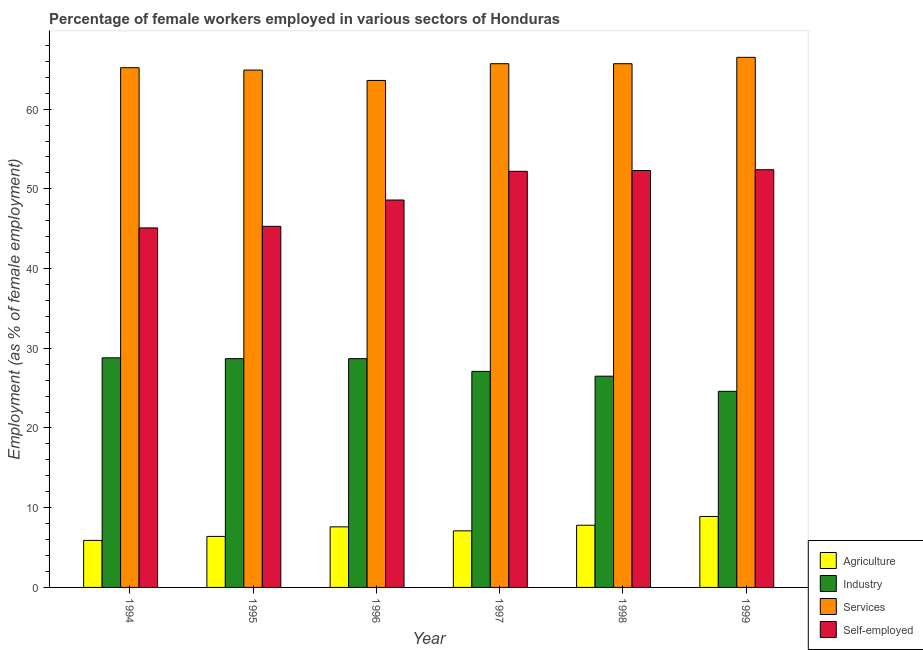How many different coloured bars are there?
Your answer should be compact. 4. Are the number of bars per tick equal to the number of legend labels?
Your response must be concise. Yes. What is the label of the 3rd group of bars from the left?
Your response must be concise. 1996. In how many cases, is the number of bars for a given year not equal to the number of legend labels?
Offer a terse response. 0. What is the percentage of female workers in industry in 1999?
Give a very brief answer. 24.6. Across all years, what is the maximum percentage of female workers in agriculture?
Your answer should be compact. 8.9. Across all years, what is the minimum percentage of female workers in agriculture?
Your answer should be very brief. 5.9. What is the total percentage of self employed female workers in the graph?
Ensure brevity in your answer.  295.9. What is the difference between the percentage of female workers in agriculture in 1994 and that in 1997?
Keep it short and to the point. -1.2. What is the average percentage of female workers in industry per year?
Offer a terse response. 27.4. In how many years, is the percentage of self employed female workers greater than 12 %?
Offer a very short reply. 6. What is the ratio of the percentage of female workers in agriculture in 1994 to that in 1997?
Your answer should be compact. 0.83. Is the percentage of self employed female workers in 1995 less than that in 1999?
Your answer should be compact. Yes. Is the difference between the percentage of self employed female workers in 1994 and 1999 greater than the difference between the percentage of female workers in services in 1994 and 1999?
Ensure brevity in your answer.  No. What is the difference between the highest and the second highest percentage of female workers in agriculture?
Your answer should be compact. 1.1. What is the difference between the highest and the lowest percentage of self employed female workers?
Offer a very short reply. 7.3. In how many years, is the percentage of female workers in services greater than the average percentage of female workers in services taken over all years?
Your answer should be compact. 3. What does the 2nd bar from the left in 1996 represents?
Ensure brevity in your answer.  Industry. What does the 3rd bar from the right in 1998 represents?
Offer a very short reply. Industry. Are all the bars in the graph horizontal?
Offer a very short reply. No. Are the values on the major ticks of Y-axis written in scientific E-notation?
Offer a very short reply. No. How many legend labels are there?
Your answer should be very brief. 4. How are the legend labels stacked?
Keep it short and to the point. Vertical. What is the title of the graph?
Offer a very short reply. Percentage of female workers employed in various sectors of Honduras. Does "Grants and Revenue" appear as one of the legend labels in the graph?
Your answer should be compact. No. What is the label or title of the Y-axis?
Keep it short and to the point. Employment (as % of female employment). What is the Employment (as % of female employment) of Agriculture in 1994?
Provide a succinct answer. 5.9. What is the Employment (as % of female employment) in Industry in 1994?
Make the answer very short. 28.8. What is the Employment (as % of female employment) in Services in 1994?
Make the answer very short. 65.2. What is the Employment (as % of female employment) of Self-employed in 1994?
Provide a succinct answer. 45.1. What is the Employment (as % of female employment) of Agriculture in 1995?
Make the answer very short. 6.4. What is the Employment (as % of female employment) in Industry in 1995?
Offer a terse response. 28.7. What is the Employment (as % of female employment) of Services in 1995?
Offer a terse response. 64.9. What is the Employment (as % of female employment) of Self-employed in 1995?
Offer a terse response. 45.3. What is the Employment (as % of female employment) in Agriculture in 1996?
Your response must be concise. 7.6. What is the Employment (as % of female employment) of Industry in 1996?
Offer a terse response. 28.7. What is the Employment (as % of female employment) in Services in 1996?
Keep it short and to the point. 63.6. What is the Employment (as % of female employment) of Self-employed in 1996?
Your answer should be very brief. 48.6. What is the Employment (as % of female employment) in Agriculture in 1997?
Make the answer very short. 7.1. What is the Employment (as % of female employment) of Industry in 1997?
Give a very brief answer. 27.1. What is the Employment (as % of female employment) in Services in 1997?
Offer a very short reply. 65.7. What is the Employment (as % of female employment) of Self-employed in 1997?
Offer a terse response. 52.2. What is the Employment (as % of female employment) in Agriculture in 1998?
Ensure brevity in your answer.  7.8. What is the Employment (as % of female employment) in Industry in 1998?
Provide a short and direct response. 26.5. What is the Employment (as % of female employment) of Services in 1998?
Your answer should be compact. 65.7. What is the Employment (as % of female employment) of Self-employed in 1998?
Make the answer very short. 52.3. What is the Employment (as % of female employment) of Agriculture in 1999?
Keep it short and to the point. 8.9. What is the Employment (as % of female employment) of Industry in 1999?
Provide a short and direct response. 24.6. What is the Employment (as % of female employment) in Services in 1999?
Ensure brevity in your answer.  66.5. What is the Employment (as % of female employment) in Self-employed in 1999?
Offer a terse response. 52.4. Across all years, what is the maximum Employment (as % of female employment) of Agriculture?
Keep it short and to the point. 8.9. Across all years, what is the maximum Employment (as % of female employment) of Industry?
Your answer should be compact. 28.8. Across all years, what is the maximum Employment (as % of female employment) of Services?
Give a very brief answer. 66.5. Across all years, what is the maximum Employment (as % of female employment) in Self-employed?
Give a very brief answer. 52.4. Across all years, what is the minimum Employment (as % of female employment) in Agriculture?
Provide a short and direct response. 5.9. Across all years, what is the minimum Employment (as % of female employment) of Industry?
Ensure brevity in your answer.  24.6. Across all years, what is the minimum Employment (as % of female employment) of Services?
Your response must be concise. 63.6. Across all years, what is the minimum Employment (as % of female employment) of Self-employed?
Offer a very short reply. 45.1. What is the total Employment (as % of female employment) in Agriculture in the graph?
Offer a very short reply. 43.7. What is the total Employment (as % of female employment) in Industry in the graph?
Offer a very short reply. 164.4. What is the total Employment (as % of female employment) in Services in the graph?
Your answer should be compact. 391.6. What is the total Employment (as % of female employment) of Self-employed in the graph?
Your answer should be compact. 295.9. What is the difference between the Employment (as % of female employment) of Agriculture in 1994 and that in 1995?
Offer a very short reply. -0.5. What is the difference between the Employment (as % of female employment) of Industry in 1994 and that in 1995?
Ensure brevity in your answer.  0.1. What is the difference between the Employment (as % of female employment) of Services in 1994 and that in 1995?
Keep it short and to the point. 0.3. What is the difference between the Employment (as % of female employment) in Agriculture in 1994 and that in 1996?
Offer a very short reply. -1.7. What is the difference between the Employment (as % of female employment) in Industry in 1994 and that in 1996?
Provide a short and direct response. 0.1. What is the difference between the Employment (as % of female employment) of Agriculture in 1994 and that in 1997?
Your answer should be very brief. -1.2. What is the difference between the Employment (as % of female employment) of Industry in 1994 and that in 1997?
Provide a succinct answer. 1.7. What is the difference between the Employment (as % of female employment) in Industry in 1994 and that in 1998?
Give a very brief answer. 2.3. What is the difference between the Employment (as % of female employment) of Services in 1994 and that in 1998?
Offer a very short reply. -0.5. What is the difference between the Employment (as % of female employment) in Industry in 1994 and that in 1999?
Give a very brief answer. 4.2. What is the difference between the Employment (as % of female employment) in Agriculture in 1995 and that in 1996?
Offer a terse response. -1.2. What is the difference between the Employment (as % of female employment) of Services in 1995 and that in 1996?
Your answer should be compact. 1.3. What is the difference between the Employment (as % of female employment) of Agriculture in 1995 and that in 1997?
Offer a terse response. -0.7. What is the difference between the Employment (as % of female employment) of Agriculture in 1995 and that in 1998?
Make the answer very short. -1.4. What is the difference between the Employment (as % of female employment) of Industry in 1995 and that in 1998?
Your answer should be compact. 2.2. What is the difference between the Employment (as % of female employment) in Self-employed in 1995 and that in 1998?
Provide a succinct answer. -7. What is the difference between the Employment (as % of female employment) in Agriculture in 1995 and that in 1999?
Provide a succinct answer. -2.5. What is the difference between the Employment (as % of female employment) of Services in 1995 and that in 1999?
Give a very brief answer. -1.6. What is the difference between the Employment (as % of female employment) in Industry in 1996 and that in 1997?
Make the answer very short. 1.6. What is the difference between the Employment (as % of female employment) in Services in 1996 and that in 1998?
Your response must be concise. -2.1. What is the difference between the Employment (as % of female employment) of Self-employed in 1996 and that in 1998?
Keep it short and to the point. -3.7. What is the difference between the Employment (as % of female employment) in Services in 1996 and that in 1999?
Offer a terse response. -2.9. What is the difference between the Employment (as % of female employment) of Agriculture in 1997 and that in 1998?
Make the answer very short. -0.7. What is the difference between the Employment (as % of female employment) of Services in 1997 and that in 1998?
Your response must be concise. 0. What is the difference between the Employment (as % of female employment) in Industry in 1997 and that in 1999?
Offer a terse response. 2.5. What is the difference between the Employment (as % of female employment) in Services in 1997 and that in 1999?
Keep it short and to the point. -0.8. What is the difference between the Employment (as % of female employment) in Self-employed in 1997 and that in 1999?
Your answer should be very brief. -0.2. What is the difference between the Employment (as % of female employment) in Agriculture in 1998 and that in 1999?
Give a very brief answer. -1.1. What is the difference between the Employment (as % of female employment) of Industry in 1998 and that in 1999?
Keep it short and to the point. 1.9. What is the difference between the Employment (as % of female employment) of Services in 1998 and that in 1999?
Offer a terse response. -0.8. What is the difference between the Employment (as % of female employment) of Agriculture in 1994 and the Employment (as % of female employment) of Industry in 1995?
Keep it short and to the point. -22.8. What is the difference between the Employment (as % of female employment) in Agriculture in 1994 and the Employment (as % of female employment) in Services in 1995?
Keep it short and to the point. -59. What is the difference between the Employment (as % of female employment) in Agriculture in 1994 and the Employment (as % of female employment) in Self-employed in 1995?
Provide a short and direct response. -39.4. What is the difference between the Employment (as % of female employment) of Industry in 1994 and the Employment (as % of female employment) of Services in 1995?
Ensure brevity in your answer.  -36.1. What is the difference between the Employment (as % of female employment) of Industry in 1994 and the Employment (as % of female employment) of Self-employed in 1995?
Provide a short and direct response. -16.5. What is the difference between the Employment (as % of female employment) in Services in 1994 and the Employment (as % of female employment) in Self-employed in 1995?
Your answer should be very brief. 19.9. What is the difference between the Employment (as % of female employment) of Agriculture in 1994 and the Employment (as % of female employment) of Industry in 1996?
Offer a terse response. -22.8. What is the difference between the Employment (as % of female employment) of Agriculture in 1994 and the Employment (as % of female employment) of Services in 1996?
Offer a very short reply. -57.7. What is the difference between the Employment (as % of female employment) of Agriculture in 1994 and the Employment (as % of female employment) of Self-employed in 1996?
Your answer should be compact. -42.7. What is the difference between the Employment (as % of female employment) of Industry in 1994 and the Employment (as % of female employment) of Services in 1996?
Provide a short and direct response. -34.8. What is the difference between the Employment (as % of female employment) of Industry in 1994 and the Employment (as % of female employment) of Self-employed in 1996?
Provide a succinct answer. -19.8. What is the difference between the Employment (as % of female employment) in Agriculture in 1994 and the Employment (as % of female employment) in Industry in 1997?
Offer a terse response. -21.2. What is the difference between the Employment (as % of female employment) of Agriculture in 1994 and the Employment (as % of female employment) of Services in 1997?
Provide a succinct answer. -59.8. What is the difference between the Employment (as % of female employment) of Agriculture in 1994 and the Employment (as % of female employment) of Self-employed in 1997?
Your response must be concise. -46.3. What is the difference between the Employment (as % of female employment) in Industry in 1994 and the Employment (as % of female employment) in Services in 1997?
Provide a short and direct response. -36.9. What is the difference between the Employment (as % of female employment) of Industry in 1994 and the Employment (as % of female employment) of Self-employed in 1997?
Ensure brevity in your answer.  -23.4. What is the difference between the Employment (as % of female employment) in Agriculture in 1994 and the Employment (as % of female employment) in Industry in 1998?
Provide a succinct answer. -20.6. What is the difference between the Employment (as % of female employment) in Agriculture in 1994 and the Employment (as % of female employment) in Services in 1998?
Offer a very short reply. -59.8. What is the difference between the Employment (as % of female employment) of Agriculture in 1994 and the Employment (as % of female employment) of Self-employed in 1998?
Provide a short and direct response. -46.4. What is the difference between the Employment (as % of female employment) in Industry in 1994 and the Employment (as % of female employment) in Services in 1998?
Offer a terse response. -36.9. What is the difference between the Employment (as % of female employment) in Industry in 1994 and the Employment (as % of female employment) in Self-employed in 1998?
Your answer should be compact. -23.5. What is the difference between the Employment (as % of female employment) in Services in 1994 and the Employment (as % of female employment) in Self-employed in 1998?
Your response must be concise. 12.9. What is the difference between the Employment (as % of female employment) in Agriculture in 1994 and the Employment (as % of female employment) in Industry in 1999?
Provide a succinct answer. -18.7. What is the difference between the Employment (as % of female employment) in Agriculture in 1994 and the Employment (as % of female employment) in Services in 1999?
Keep it short and to the point. -60.6. What is the difference between the Employment (as % of female employment) in Agriculture in 1994 and the Employment (as % of female employment) in Self-employed in 1999?
Provide a short and direct response. -46.5. What is the difference between the Employment (as % of female employment) in Industry in 1994 and the Employment (as % of female employment) in Services in 1999?
Provide a short and direct response. -37.7. What is the difference between the Employment (as % of female employment) of Industry in 1994 and the Employment (as % of female employment) of Self-employed in 1999?
Ensure brevity in your answer.  -23.6. What is the difference between the Employment (as % of female employment) of Agriculture in 1995 and the Employment (as % of female employment) of Industry in 1996?
Give a very brief answer. -22.3. What is the difference between the Employment (as % of female employment) of Agriculture in 1995 and the Employment (as % of female employment) of Services in 1996?
Keep it short and to the point. -57.2. What is the difference between the Employment (as % of female employment) in Agriculture in 1995 and the Employment (as % of female employment) in Self-employed in 1996?
Offer a very short reply. -42.2. What is the difference between the Employment (as % of female employment) of Industry in 1995 and the Employment (as % of female employment) of Services in 1996?
Your answer should be compact. -34.9. What is the difference between the Employment (as % of female employment) of Industry in 1995 and the Employment (as % of female employment) of Self-employed in 1996?
Offer a very short reply. -19.9. What is the difference between the Employment (as % of female employment) in Agriculture in 1995 and the Employment (as % of female employment) in Industry in 1997?
Keep it short and to the point. -20.7. What is the difference between the Employment (as % of female employment) in Agriculture in 1995 and the Employment (as % of female employment) in Services in 1997?
Your answer should be compact. -59.3. What is the difference between the Employment (as % of female employment) in Agriculture in 1995 and the Employment (as % of female employment) in Self-employed in 1997?
Your answer should be compact. -45.8. What is the difference between the Employment (as % of female employment) in Industry in 1995 and the Employment (as % of female employment) in Services in 1997?
Your answer should be compact. -37. What is the difference between the Employment (as % of female employment) in Industry in 1995 and the Employment (as % of female employment) in Self-employed in 1997?
Your answer should be compact. -23.5. What is the difference between the Employment (as % of female employment) in Agriculture in 1995 and the Employment (as % of female employment) in Industry in 1998?
Provide a succinct answer. -20.1. What is the difference between the Employment (as % of female employment) of Agriculture in 1995 and the Employment (as % of female employment) of Services in 1998?
Keep it short and to the point. -59.3. What is the difference between the Employment (as % of female employment) in Agriculture in 1995 and the Employment (as % of female employment) in Self-employed in 1998?
Your answer should be compact. -45.9. What is the difference between the Employment (as % of female employment) in Industry in 1995 and the Employment (as % of female employment) in Services in 1998?
Provide a short and direct response. -37. What is the difference between the Employment (as % of female employment) of Industry in 1995 and the Employment (as % of female employment) of Self-employed in 1998?
Ensure brevity in your answer.  -23.6. What is the difference between the Employment (as % of female employment) of Agriculture in 1995 and the Employment (as % of female employment) of Industry in 1999?
Your answer should be very brief. -18.2. What is the difference between the Employment (as % of female employment) in Agriculture in 1995 and the Employment (as % of female employment) in Services in 1999?
Provide a succinct answer. -60.1. What is the difference between the Employment (as % of female employment) in Agriculture in 1995 and the Employment (as % of female employment) in Self-employed in 1999?
Provide a short and direct response. -46. What is the difference between the Employment (as % of female employment) in Industry in 1995 and the Employment (as % of female employment) in Services in 1999?
Offer a terse response. -37.8. What is the difference between the Employment (as % of female employment) in Industry in 1995 and the Employment (as % of female employment) in Self-employed in 1999?
Your response must be concise. -23.7. What is the difference between the Employment (as % of female employment) in Agriculture in 1996 and the Employment (as % of female employment) in Industry in 1997?
Your response must be concise. -19.5. What is the difference between the Employment (as % of female employment) in Agriculture in 1996 and the Employment (as % of female employment) in Services in 1997?
Your answer should be compact. -58.1. What is the difference between the Employment (as % of female employment) of Agriculture in 1996 and the Employment (as % of female employment) of Self-employed in 1997?
Offer a terse response. -44.6. What is the difference between the Employment (as % of female employment) of Industry in 1996 and the Employment (as % of female employment) of Services in 1997?
Your answer should be compact. -37. What is the difference between the Employment (as % of female employment) of Industry in 1996 and the Employment (as % of female employment) of Self-employed in 1997?
Your answer should be compact. -23.5. What is the difference between the Employment (as % of female employment) in Services in 1996 and the Employment (as % of female employment) in Self-employed in 1997?
Offer a terse response. 11.4. What is the difference between the Employment (as % of female employment) of Agriculture in 1996 and the Employment (as % of female employment) of Industry in 1998?
Your answer should be compact. -18.9. What is the difference between the Employment (as % of female employment) of Agriculture in 1996 and the Employment (as % of female employment) of Services in 1998?
Provide a short and direct response. -58.1. What is the difference between the Employment (as % of female employment) in Agriculture in 1996 and the Employment (as % of female employment) in Self-employed in 1998?
Your answer should be compact. -44.7. What is the difference between the Employment (as % of female employment) in Industry in 1996 and the Employment (as % of female employment) in Services in 1998?
Your response must be concise. -37. What is the difference between the Employment (as % of female employment) of Industry in 1996 and the Employment (as % of female employment) of Self-employed in 1998?
Keep it short and to the point. -23.6. What is the difference between the Employment (as % of female employment) of Agriculture in 1996 and the Employment (as % of female employment) of Industry in 1999?
Provide a short and direct response. -17. What is the difference between the Employment (as % of female employment) in Agriculture in 1996 and the Employment (as % of female employment) in Services in 1999?
Your answer should be compact. -58.9. What is the difference between the Employment (as % of female employment) of Agriculture in 1996 and the Employment (as % of female employment) of Self-employed in 1999?
Provide a short and direct response. -44.8. What is the difference between the Employment (as % of female employment) in Industry in 1996 and the Employment (as % of female employment) in Services in 1999?
Give a very brief answer. -37.8. What is the difference between the Employment (as % of female employment) in Industry in 1996 and the Employment (as % of female employment) in Self-employed in 1999?
Keep it short and to the point. -23.7. What is the difference between the Employment (as % of female employment) of Services in 1996 and the Employment (as % of female employment) of Self-employed in 1999?
Your response must be concise. 11.2. What is the difference between the Employment (as % of female employment) in Agriculture in 1997 and the Employment (as % of female employment) in Industry in 1998?
Provide a succinct answer. -19.4. What is the difference between the Employment (as % of female employment) in Agriculture in 1997 and the Employment (as % of female employment) in Services in 1998?
Provide a short and direct response. -58.6. What is the difference between the Employment (as % of female employment) of Agriculture in 1997 and the Employment (as % of female employment) of Self-employed in 1998?
Give a very brief answer. -45.2. What is the difference between the Employment (as % of female employment) in Industry in 1997 and the Employment (as % of female employment) in Services in 1998?
Give a very brief answer. -38.6. What is the difference between the Employment (as % of female employment) of Industry in 1997 and the Employment (as % of female employment) of Self-employed in 1998?
Make the answer very short. -25.2. What is the difference between the Employment (as % of female employment) in Agriculture in 1997 and the Employment (as % of female employment) in Industry in 1999?
Provide a short and direct response. -17.5. What is the difference between the Employment (as % of female employment) of Agriculture in 1997 and the Employment (as % of female employment) of Services in 1999?
Offer a very short reply. -59.4. What is the difference between the Employment (as % of female employment) in Agriculture in 1997 and the Employment (as % of female employment) in Self-employed in 1999?
Ensure brevity in your answer.  -45.3. What is the difference between the Employment (as % of female employment) in Industry in 1997 and the Employment (as % of female employment) in Services in 1999?
Your response must be concise. -39.4. What is the difference between the Employment (as % of female employment) in Industry in 1997 and the Employment (as % of female employment) in Self-employed in 1999?
Keep it short and to the point. -25.3. What is the difference between the Employment (as % of female employment) in Agriculture in 1998 and the Employment (as % of female employment) in Industry in 1999?
Ensure brevity in your answer.  -16.8. What is the difference between the Employment (as % of female employment) of Agriculture in 1998 and the Employment (as % of female employment) of Services in 1999?
Your response must be concise. -58.7. What is the difference between the Employment (as % of female employment) of Agriculture in 1998 and the Employment (as % of female employment) of Self-employed in 1999?
Provide a short and direct response. -44.6. What is the difference between the Employment (as % of female employment) of Industry in 1998 and the Employment (as % of female employment) of Self-employed in 1999?
Make the answer very short. -25.9. What is the average Employment (as % of female employment) of Agriculture per year?
Offer a terse response. 7.28. What is the average Employment (as % of female employment) of Industry per year?
Make the answer very short. 27.4. What is the average Employment (as % of female employment) in Services per year?
Offer a very short reply. 65.27. What is the average Employment (as % of female employment) in Self-employed per year?
Ensure brevity in your answer.  49.32. In the year 1994, what is the difference between the Employment (as % of female employment) of Agriculture and Employment (as % of female employment) of Industry?
Keep it short and to the point. -22.9. In the year 1994, what is the difference between the Employment (as % of female employment) of Agriculture and Employment (as % of female employment) of Services?
Your answer should be compact. -59.3. In the year 1994, what is the difference between the Employment (as % of female employment) of Agriculture and Employment (as % of female employment) of Self-employed?
Provide a succinct answer. -39.2. In the year 1994, what is the difference between the Employment (as % of female employment) of Industry and Employment (as % of female employment) of Services?
Provide a short and direct response. -36.4. In the year 1994, what is the difference between the Employment (as % of female employment) in Industry and Employment (as % of female employment) in Self-employed?
Your answer should be compact. -16.3. In the year 1994, what is the difference between the Employment (as % of female employment) of Services and Employment (as % of female employment) of Self-employed?
Provide a succinct answer. 20.1. In the year 1995, what is the difference between the Employment (as % of female employment) in Agriculture and Employment (as % of female employment) in Industry?
Your answer should be very brief. -22.3. In the year 1995, what is the difference between the Employment (as % of female employment) in Agriculture and Employment (as % of female employment) in Services?
Ensure brevity in your answer.  -58.5. In the year 1995, what is the difference between the Employment (as % of female employment) of Agriculture and Employment (as % of female employment) of Self-employed?
Make the answer very short. -38.9. In the year 1995, what is the difference between the Employment (as % of female employment) in Industry and Employment (as % of female employment) in Services?
Offer a very short reply. -36.2. In the year 1995, what is the difference between the Employment (as % of female employment) of Industry and Employment (as % of female employment) of Self-employed?
Keep it short and to the point. -16.6. In the year 1995, what is the difference between the Employment (as % of female employment) in Services and Employment (as % of female employment) in Self-employed?
Provide a short and direct response. 19.6. In the year 1996, what is the difference between the Employment (as % of female employment) of Agriculture and Employment (as % of female employment) of Industry?
Give a very brief answer. -21.1. In the year 1996, what is the difference between the Employment (as % of female employment) of Agriculture and Employment (as % of female employment) of Services?
Offer a very short reply. -56. In the year 1996, what is the difference between the Employment (as % of female employment) in Agriculture and Employment (as % of female employment) in Self-employed?
Provide a succinct answer. -41. In the year 1996, what is the difference between the Employment (as % of female employment) in Industry and Employment (as % of female employment) in Services?
Your answer should be very brief. -34.9. In the year 1996, what is the difference between the Employment (as % of female employment) of Industry and Employment (as % of female employment) of Self-employed?
Make the answer very short. -19.9. In the year 1997, what is the difference between the Employment (as % of female employment) in Agriculture and Employment (as % of female employment) in Services?
Make the answer very short. -58.6. In the year 1997, what is the difference between the Employment (as % of female employment) in Agriculture and Employment (as % of female employment) in Self-employed?
Keep it short and to the point. -45.1. In the year 1997, what is the difference between the Employment (as % of female employment) in Industry and Employment (as % of female employment) in Services?
Ensure brevity in your answer.  -38.6. In the year 1997, what is the difference between the Employment (as % of female employment) in Industry and Employment (as % of female employment) in Self-employed?
Provide a short and direct response. -25.1. In the year 1998, what is the difference between the Employment (as % of female employment) in Agriculture and Employment (as % of female employment) in Industry?
Give a very brief answer. -18.7. In the year 1998, what is the difference between the Employment (as % of female employment) in Agriculture and Employment (as % of female employment) in Services?
Offer a very short reply. -57.9. In the year 1998, what is the difference between the Employment (as % of female employment) in Agriculture and Employment (as % of female employment) in Self-employed?
Provide a short and direct response. -44.5. In the year 1998, what is the difference between the Employment (as % of female employment) in Industry and Employment (as % of female employment) in Services?
Offer a terse response. -39.2. In the year 1998, what is the difference between the Employment (as % of female employment) of Industry and Employment (as % of female employment) of Self-employed?
Provide a succinct answer. -25.8. In the year 1998, what is the difference between the Employment (as % of female employment) in Services and Employment (as % of female employment) in Self-employed?
Provide a short and direct response. 13.4. In the year 1999, what is the difference between the Employment (as % of female employment) in Agriculture and Employment (as % of female employment) in Industry?
Provide a succinct answer. -15.7. In the year 1999, what is the difference between the Employment (as % of female employment) in Agriculture and Employment (as % of female employment) in Services?
Make the answer very short. -57.6. In the year 1999, what is the difference between the Employment (as % of female employment) in Agriculture and Employment (as % of female employment) in Self-employed?
Offer a very short reply. -43.5. In the year 1999, what is the difference between the Employment (as % of female employment) in Industry and Employment (as % of female employment) in Services?
Make the answer very short. -41.9. In the year 1999, what is the difference between the Employment (as % of female employment) of Industry and Employment (as % of female employment) of Self-employed?
Keep it short and to the point. -27.8. In the year 1999, what is the difference between the Employment (as % of female employment) in Services and Employment (as % of female employment) in Self-employed?
Give a very brief answer. 14.1. What is the ratio of the Employment (as % of female employment) of Agriculture in 1994 to that in 1995?
Keep it short and to the point. 0.92. What is the ratio of the Employment (as % of female employment) of Industry in 1994 to that in 1995?
Your response must be concise. 1. What is the ratio of the Employment (as % of female employment) in Agriculture in 1994 to that in 1996?
Ensure brevity in your answer.  0.78. What is the ratio of the Employment (as % of female employment) in Industry in 1994 to that in 1996?
Your answer should be compact. 1. What is the ratio of the Employment (as % of female employment) of Services in 1994 to that in 1996?
Offer a very short reply. 1.03. What is the ratio of the Employment (as % of female employment) of Self-employed in 1994 to that in 1996?
Keep it short and to the point. 0.93. What is the ratio of the Employment (as % of female employment) of Agriculture in 1994 to that in 1997?
Offer a terse response. 0.83. What is the ratio of the Employment (as % of female employment) in Industry in 1994 to that in 1997?
Give a very brief answer. 1.06. What is the ratio of the Employment (as % of female employment) of Self-employed in 1994 to that in 1997?
Give a very brief answer. 0.86. What is the ratio of the Employment (as % of female employment) of Agriculture in 1994 to that in 1998?
Your answer should be compact. 0.76. What is the ratio of the Employment (as % of female employment) of Industry in 1994 to that in 1998?
Your response must be concise. 1.09. What is the ratio of the Employment (as % of female employment) in Self-employed in 1994 to that in 1998?
Give a very brief answer. 0.86. What is the ratio of the Employment (as % of female employment) of Agriculture in 1994 to that in 1999?
Keep it short and to the point. 0.66. What is the ratio of the Employment (as % of female employment) of Industry in 1994 to that in 1999?
Keep it short and to the point. 1.17. What is the ratio of the Employment (as % of female employment) of Services in 1994 to that in 1999?
Your answer should be very brief. 0.98. What is the ratio of the Employment (as % of female employment) in Self-employed in 1994 to that in 1999?
Provide a short and direct response. 0.86. What is the ratio of the Employment (as % of female employment) in Agriculture in 1995 to that in 1996?
Provide a short and direct response. 0.84. What is the ratio of the Employment (as % of female employment) in Services in 1995 to that in 1996?
Offer a terse response. 1.02. What is the ratio of the Employment (as % of female employment) of Self-employed in 1995 to that in 1996?
Offer a terse response. 0.93. What is the ratio of the Employment (as % of female employment) in Agriculture in 1995 to that in 1997?
Offer a very short reply. 0.9. What is the ratio of the Employment (as % of female employment) in Industry in 1995 to that in 1997?
Make the answer very short. 1.06. What is the ratio of the Employment (as % of female employment) of Services in 1995 to that in 1997?
Provide a short and direct response. 0.99. What is the ratio of the Employment (as % of female employment) of Self-employed in 1995 to that in 1997?
Keep it short and to the point. 0.87. What is the ratio of the Employment (as % of female employment) of Agriculture in 1995 to that in 1998?
Provide a succinct answer. 0.82. What is the ratio of the Employment (as % of female employment) of Industry in 1995 to that in 1998?
Give a very brief answer. 1.08. What is the ratio of the Employment (as % of female employment) of Services in 1995 to that in 1998?
Provide a short and direct response. 0.99. What is the ratio of the Employment (as % of female employment) of Self-employed in 1995 to that in 1998?
Your answer should be very brief. 0.87. What is the ratio of the Employment (as % of female employment) of Agriculture in 1995 to that in 1999?
Make the answer very short. 0.72. What is the ratio of the Employment (as % of female employment) of Services in 1995 to that in 1999?
Provide a succinct answer. 0.98. What is the ratio of the Employment (as % of female employment) in Self-employed in 1995 to that in 1999?
Your answer should be compact. 0.86. What is the ratio of the Employment (as % of female employment) of Agriculture in 1996 to that in 1997?
Your answer should be very brief. 1.07. What is the ratio of the Employment (as % of female employment) of Industry in 1996 to that in 1997?
Offer a terse response. 1.06. What is the ratio of the Employment (as % of female employment) in Agriculture in 1996 to that in 1998?
Give a very brief answer. 0.97. What is the ratio of the Employment (as % of female employment) of Industry in 1996 to that in 1998?
Provide a succinct answer. 1.08. What is the ratio of the Employment (as % of female employment) of Services in 1996 to that in 1998?
Keep it short and to the point. 0.97. What is the ratio of the Employment (as % of female employment) in Self-employed in 1996 to that in 1998?
Provide a succinct answer. 0.93. What is the ratio of the Employment (as % of female employment) of Agriculture in 1996 to that in 1999?
Offer a very short reply. 0.85. What is the ratio of the Employment (as % of female employment) in Industry in 1996 to that in 1999?
Your answer should be compact. 1.17. What is the ratio of the Employment (as % of female employment) of Services in 1996 to that in 1999?
Offer a very short reply. 0.96. What is the ratio of the Employment (as % of female employment) of Self-employed in 1996 to that in 1999?
Provide a short and direct response. 0.93. What is the ratio of the Employment (as % of female employment) of Agriculture in 1997 to that in 1998?
Your answer should be compact. 0.91. What is the ratio of the Employment (as % of female employment) of Industry in 1997 to that in 1998?
Ensure brevity in your answer.  1.02. What is the ratio of the Employment (as % of female employment) in Services in 1997 to that in 1998?
Make the answer very short. 1. What is the ratio of the Employment (as % of female employment) in Agriculture in 1997 to that in 1999?
Offer a terse response. 0.8. What is the ratio of the Employment (as % of female employment) of Industry in 1997 to that in 1999?
Your answer should be compact. 1.1. What is the ratio of the Employment (as % of female employment) in Services in 1997 to that in 1999?
Ensure brevity in your answer.  0.99. What is the ratio of the Employment (as % of female employment) of Self-employed in 1997 to that in 1999?
Your answer should be very brief. 1. What is the ratio of the Employment (as % of female employment) of Agriculture in 1998 to that in 1999?
Keep it short and to the point. 0.88. What is the ratio of the Employment (as % of female employment) in Industry in 1998 to that in 1999?
Your response must be concise. 1.08. What is the ratio of the Employment (as % of female employment) of Services in 1998 to that in 1999?
Keep it short and to the point. 0.99. What is the ratio of the Employment (as % of female employment) in Self-employed in 1998 to that in 1999?
Ensure brevity in your answer.  1. What is the difference between the highest and the second highest Employment (as % of female employment) of Agriculture?
Make the answer very short. 1.1. What is the difference between the highest and the second highest Employment (as % of female employment) in Industry?
Your answer should be very brief. 0.1. What is the difference between the highest and the second highest Employment (as % of female employment) of Services?
Your answer should be very brief. 0.8. What is the difference between the highest and the second highest Employment (as % of female employment) of Self-employed?
Offer a very short reply. 0.1. What is the difference between the highest and the lowest Employment (as % of female employment) in Agriculture?
Ensure brevity in your answer.  3. What is the difference between the highest and the lowest Employment (as % of female employment) of Services?
Offer a very short reply. 2.9. What is the difference between the highest and the lowest Employment (as % of female employment) in Self-employed?
Ensure brevity in your answer.  7.3. 